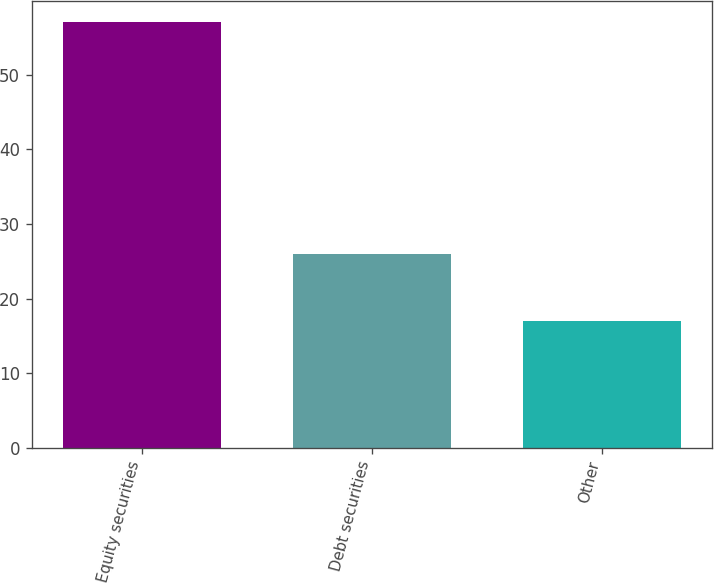Convert chart to OTSL. <chart><loc_0><loc_0><loc_500><loc_500><bar_chart><fcel>Equity securities<fcel>Debt securities<fcel>Other<nl><fcel>57<fcel>26<fcel>17<nl></chart> 